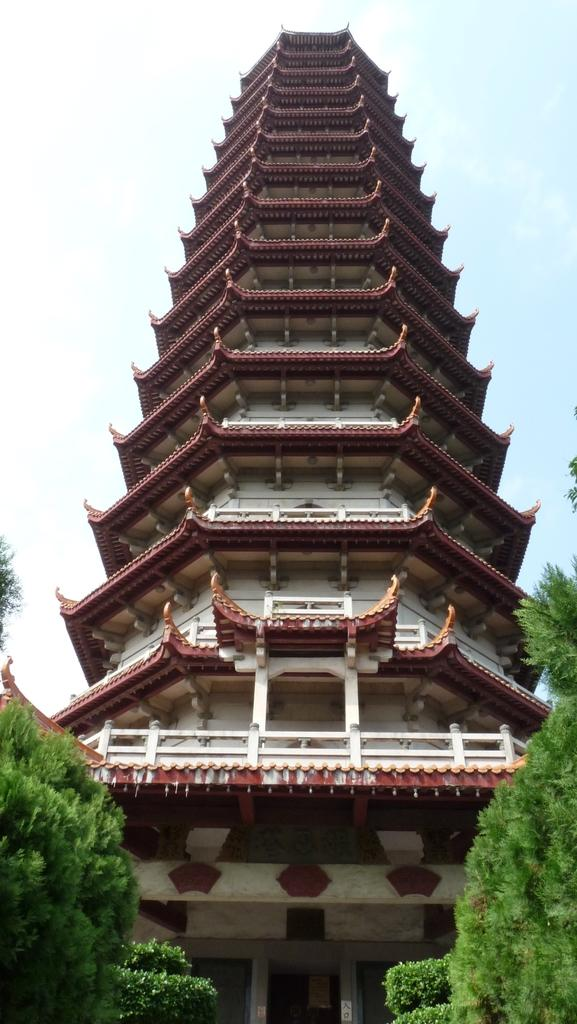What is the main structure in the picture? There is a tower in the picture. What can be seen on both sides of the picture? There are trees on the right side and the left side of the picture. What is the condition of the sky in the picture? The sky is clear in the picture. What is the weather like in the picture? It is sunny in the picture. Can you see a lake in the picture? There is no lake present in the image. Is there a rabbit visible in the picture? There is no rabbit present in the image. 